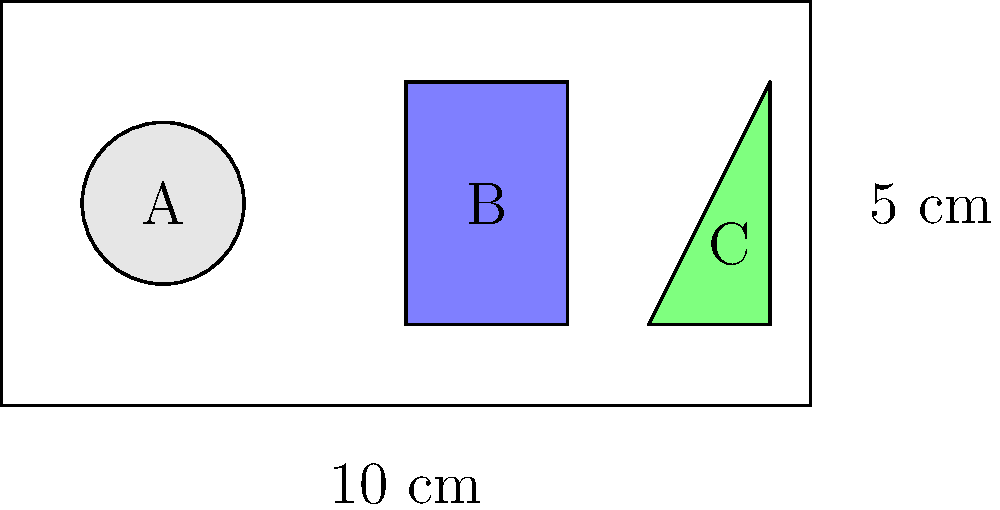You have a shelf that is 10 cm wide and 5 cm tall. Three types of products need to be arranged on this shelf: cylindrical (A), rectangular (B), and triangular (C). Given that each product type occupies the same volume but has different shapes, which arrangement would maximize the number of products that can fit on the shelf? To maximize the number of products on the shelf, we need to consider the efficient use of space for each product shape:

1. Cylindrical products (A):
   - These leave empty spaces between them when arranged.
   - Efficiency: Approximately 78.5% (π/4) of the square area they occupy.

2. Rectangular products (B):
   - These can be stacked efficiently with no wasted space.
   - Efficiency: 100% of the area they occupy.

3. Triangular products (C):
   - These can be arranged in alternating orientations to minimize wasted space.
   - Efficiency: Approximately 86.6% when arranged optimally.

To maximize shelf space utilization:

1. Use rectangular products (B) as the primary shape, as they have 100% space efficiency.
2. If there's remaining space that can't fit a full rectangular product, use triangular products (C) in the corners or edges.
3. Use cylindrical products (A) only if they fit better in specific spots than the other shapes.

The optimal arrangement would be:
- Fill most of the shelf with rectangular products (B).
- Use triangular products (C) in any remaining corners or edges.
- Use cylindrical products (A) only if they fit better in specific spots than B or C.

This arrangement ensures maximum space utilization and allows for the highest number of products on the shelf.
Answer: Primarily rectangular (B), with triangular (C) in remaining spaces, and cylindrical (A) only where they fit better. 